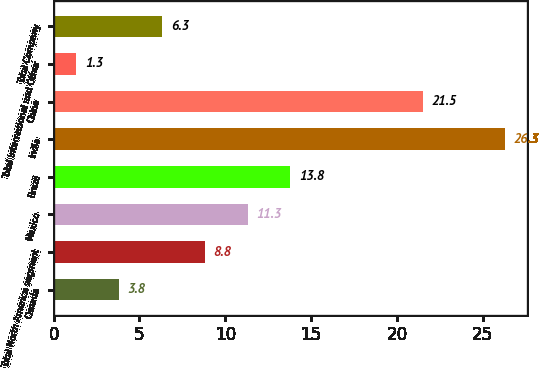<chart> <loc_0><loc_0><loc_500><loc_500><bar_chart><fcel>Canada<fcel>Total North America segment<fcel>Mexico<fcel>Brazil<fcel>India<fcel>China<fcel>Total International and Other<fcel>Total Company<nl><fcel>3.8<fcel>8.8<fcel>11.3<fcel>13.8<fcel>26.3<fcel>21.5<fcel>1.3<fcel>6.3<nl></chart> 